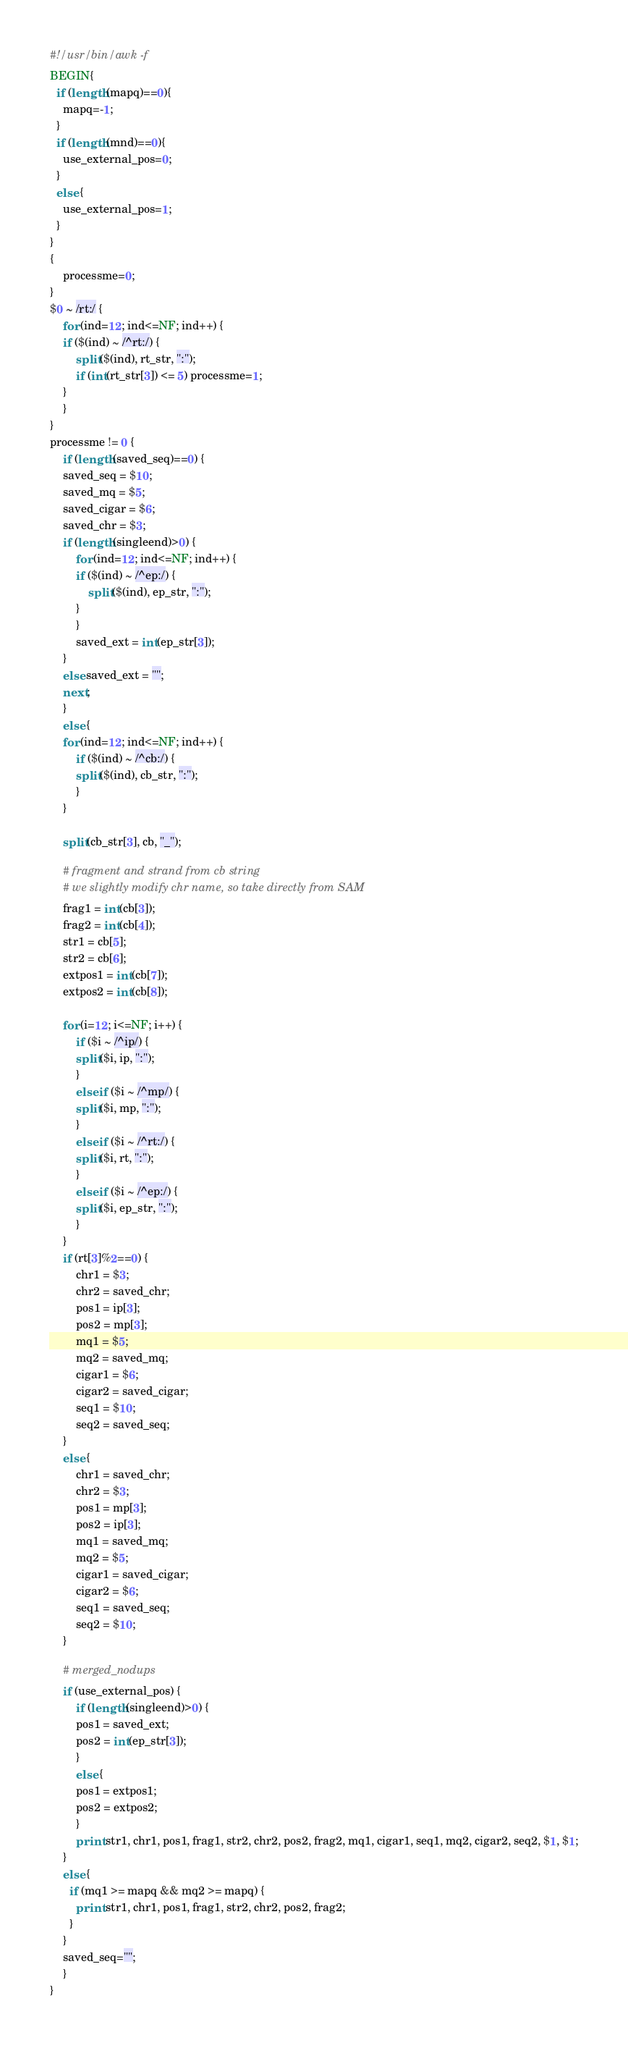<code> <loc_0><loc_0><loc_500><loc_500><_Awk_>#!/usr/bin/awk -f
BEGIN{
  if (length(mapq)==0){
    mapq=-1;
  }
  if (length(mnd)==0){
    use_external_pos=0;
  }
  else {
    use_external_pos=1;
  }
}
{
    processme=0;
}
$0 ~ /rt:/ {
    for (ind=12; ind<=NF; ind++) {
	if ($(ind) ~ /^rt:/) {
	    split($(ind), rt_str, ":");
	    if (int(rt_str[3]) <= 5) processme=1;
	} 
    }
}
processme != 0 {
    if (length(saved_seq)==0) {
	saved_seq = $10;
	saved_mq = $5;
	saved_cigar = $6;
	saved_chr = $3;
	if (length(singleend)>0) {
	    for (ind=12; ind<=NF; ind++) {
		if ($(ind) ~ /^ep:/) {
		    split($(ind), ep_str, ":");
		}
	    }
	    saved_ext = int(ep_str[3]);
	}
	else saved_ext = "";
	next;
    }
    else {
	for (ind=12; ind<=NF; ind++) {
	    if ($(ind) ~ /^cb:/) {
		split($(ind), cb_str, ":");
	    }
	}

	split(cb_str[3], cb, "_");

	# fragment and strand from cb string
	# we slightly modify chr name, so take directly from SAM
	frag1 = int(cb[3]);
	frag2 = int(cb[4]);
	str1 = cb[5];
	str2 = cb[6];
	extpos1 = int(cb[7]);
	extpos2 = int(cb[8]);
	
	for (i=12; i<=NF; i++) {
	    if ($i ~ /^ip/) {
		split($i, ip, ":");
	    }
	    else if ($i ~ /^mp/) {
		split($i, mp, ":");
	    }
	    else if ($i ~ /^rt:/) {
		split($i, rt, ":");
	    }
	    else if ($i ~ /^ep:/) {
		split($i, ep_str, ":");
	    }
	}
	if (rt[3]%2==0) {
	    chr1 = $3;
	    chr2 = saved_chr;
	    pos1 = ip[3];
	    pos2 = mp[3];
	    mq1 = $5;
	    mq2 = saved_mq;
	    cigar1 = $6;
	    cigar2 = saved_cigar;
	    seq1 = $10;
	    seq2 = saved_seq;
	}
	else {
	    chr1 = saved_chr;
	    chr2 = $3;
	    pos1 = mp[3];
	    pos2 = ip[3];
	    mq1 = saved_mq;
	    mq2 = $5;
	    cigar1 = saved_cigar;
	    cigar2 = $6;
	    seq1 = saved_seq;
	    seq2 = $10;
	}

	# merged_nodups
	if (use_external_pos) {
	    if (length(singleend)>0) {
		pos1 = saved_ext;
		pos2 = int(ep_str[3]);
	    }
	    else { 
		pos1 = extpos1;
		pos2 = extpos2;
	    }
	    print str1, chr1, pos1, frag1, str2, chr2, pos2, frag2, mq1, cigar1, seq1, mq2, cigar2, seq2, $1, $1;
	}
	else {
	  if (mq1 >= mapq && mq2 >= mapq) {
	    print str1, chr1, pos1, frag1, str2, chr2, pos2, frag2;
	  }
	}
	saved_seq="";
    }
}
</code> 